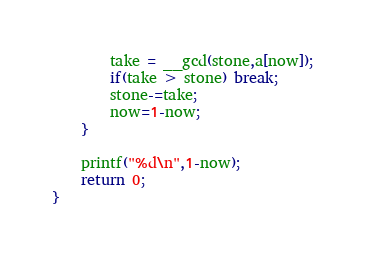<code> <loc_0><loc_0><loc_500><loc_500><_C++_>		take = __gcd(stone,a[now]);
		if(take > stone) break;
		stone-=take;
		now=1-now;
	}
	
	printf("%d\n",1-now);
	return 0;
}

</code> 